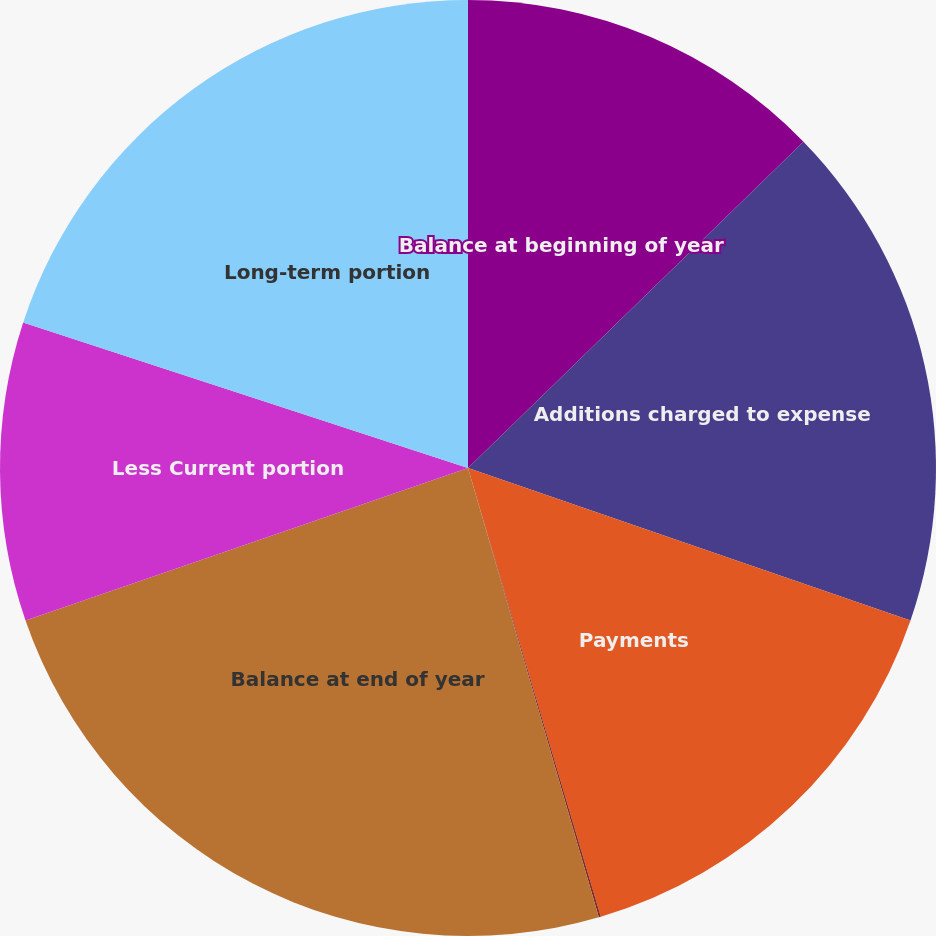Convert chart. <chart><loc_0><loc_0><loc_500><loc_500><pie_chart><fcel>Balance at beginning of year<fcel>Additions charged to expense<fcel>Payments<fcel>Accretion expense<fcel>Balance at end of year<fcel>Less Current portion<fcel>Long-term portion<nl><fcel>12.72%<fcel>17.56%<fcel>15.14%<fcel>0.07%<fcel>24.23%<fcel>10.31%<fcel>19.97%<nl></chart> 